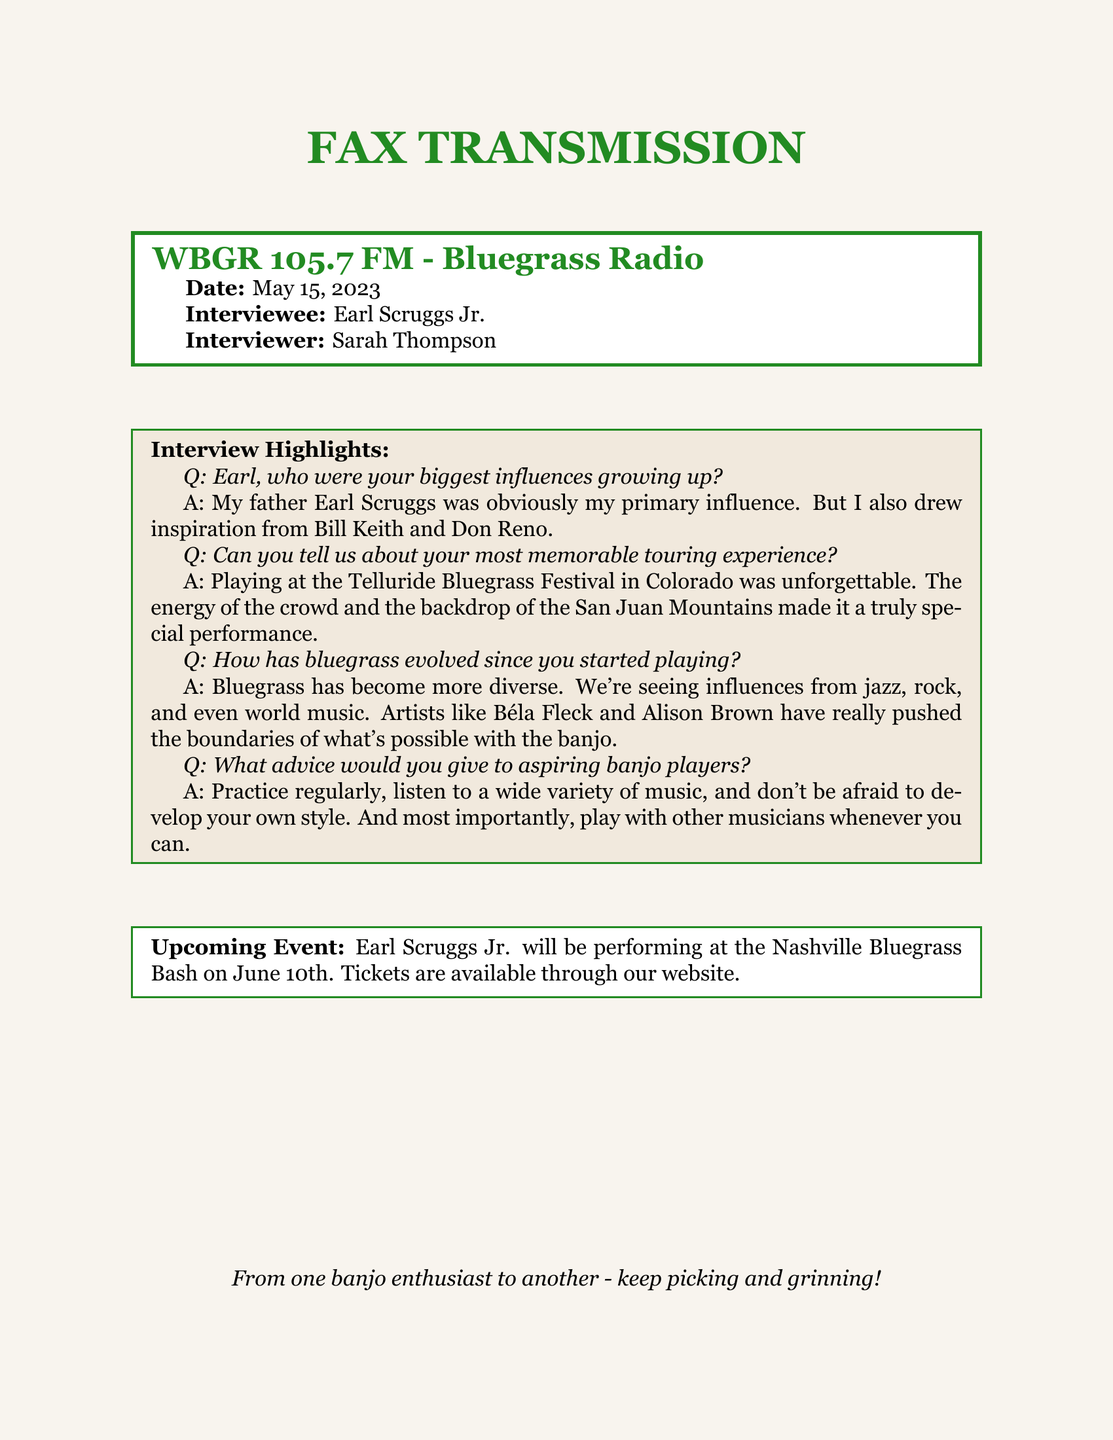What is the name of the radio station? The name of the radio station is mentioned in the header of the fax.
Answer: WBGR 105.7 FM - Bluegrass Radio Who was the interviewer for the radio interview? The interviewer's name is listed at the top of the document under "Interviewer".
Answer: Sarah Thompson When is Earl Scruggs Jr. performing next? The performance date is provided in the upcoming events section of the fax.
Answer: June 10th Which festival does Earl Scruggs Jr. mention in his most memorable touring experience? The specific festival he references in the interview highlights is stated directly.
Answer: Telluride Bluegrass Festival Who is mentioned as Earl's primary influence? The document provides a direct response from Earl about his influences, specifically naming his father.
Answer: Earl Scruggs What genres have influenced the evolution of bluegrass according to Earl? Earl mentions a variety of genres impacting bluegrass in his response.
Answer: Jazz, rock, world music What advice does Earl give for aspiring banjo players? The document summarizes Earl's advice in a specific manner.
Answer: Practice regularly, listen to a wide variety of music What kind of document is this? The structure and purpose of the content indicate its classification.
Answer: Fax transmission 